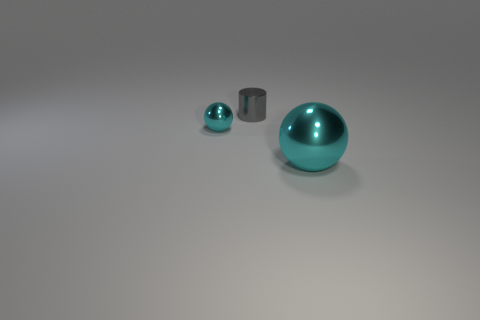Does the gray object have the same material as the big cyan ball?
Ensure brevity in your answer.  Yes. Are there more gray metallic things that are behind the gray object than big purple matte blocks?
Give a very brief answer. No. What is the small cylinder behind the cyan ball that is behind the object that is in front of the tiny cyan metallic thing made of?
Provide a short and direct response. Metal. What number of things are blue cubes or metal balls that are behind the large metal ball?
Ensure brevity in your answer.  1. Does the metal sphere to the right of the small shiny sphere have the same color as the small metal cylinder?
Ensure brevity in your answer.  No. Are there more tiny metallic balls behind the tiny metallic cylinder than spheres that are to the right of the big sphere?
Keep it short and to the point. No. Are there any other things that are the same color as the big ball?
Your answer should be compact. Yes. What number of objects are either red cylinders or metal things?
Provide a short and direct response. 3. There is a cyan ball that is right of the gray cylinder; is it the same size as the small cyan metallic object?
Offer a very short reply. No. How many other objects are there of the same size as the cylinder?
Give a very brief answer. 1. 